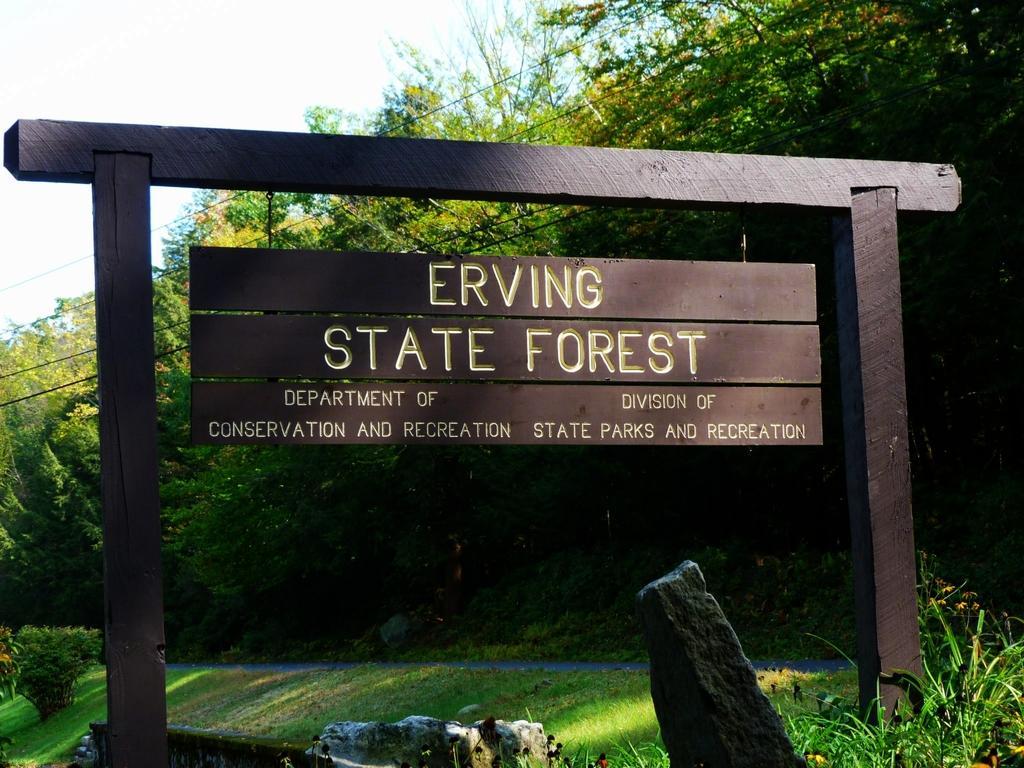How would you summarize this image in a sentence or two? In this picture I can see a board, there are plants, trees, cables, and in the background there is sky. 